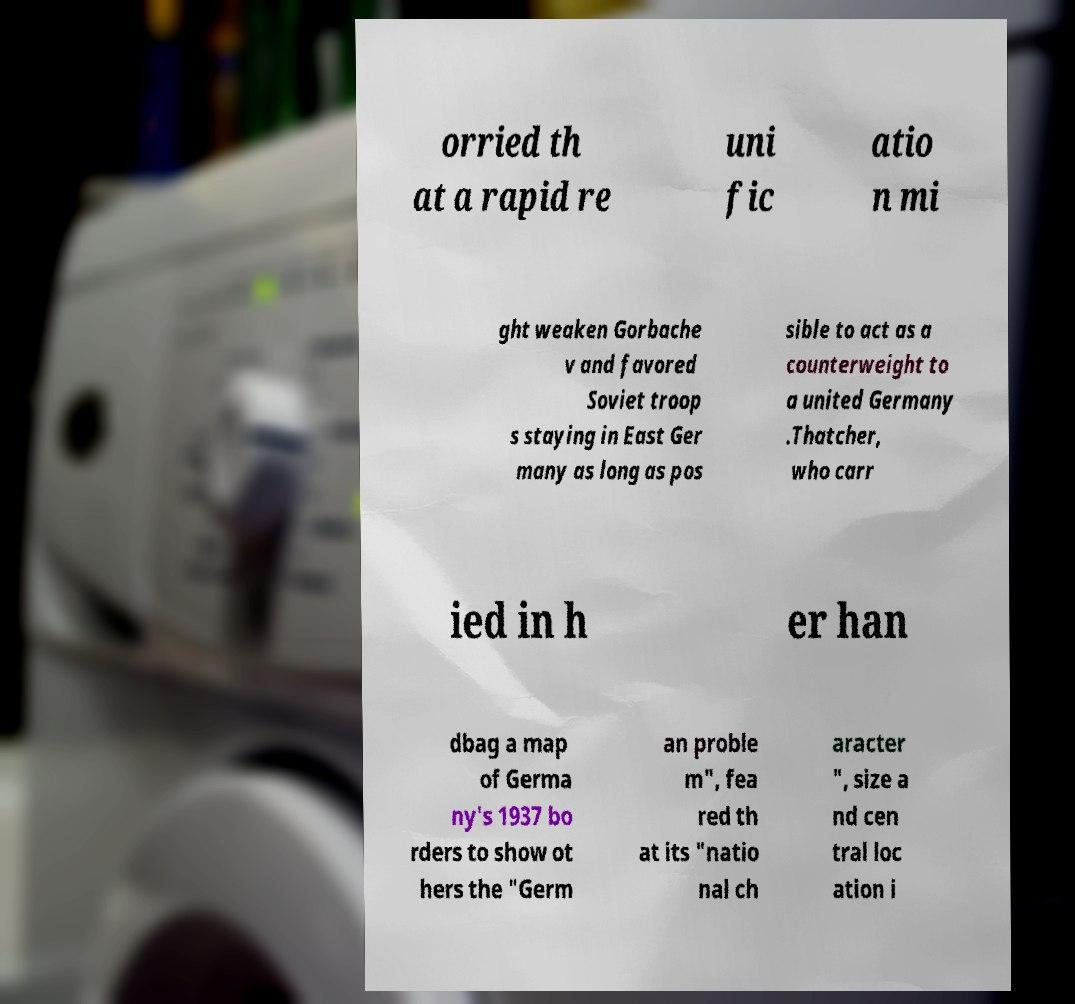Can you accurately transcribe the text from the provided image for me? orried th at a rapid re uni fic atio n mi ght weaken Gorbache v and favored Soviet troop s staying in East Ger many as long as pos sible to act as a counterweight to a united Germany .Thatcher, who carr ied in h er han dbag a map of Germa ny's 1937 bo rders to show ot hers the "Germ an proble m", fea red th at its "natio nal ch aracter ", size a nd cen tral loc ation i 